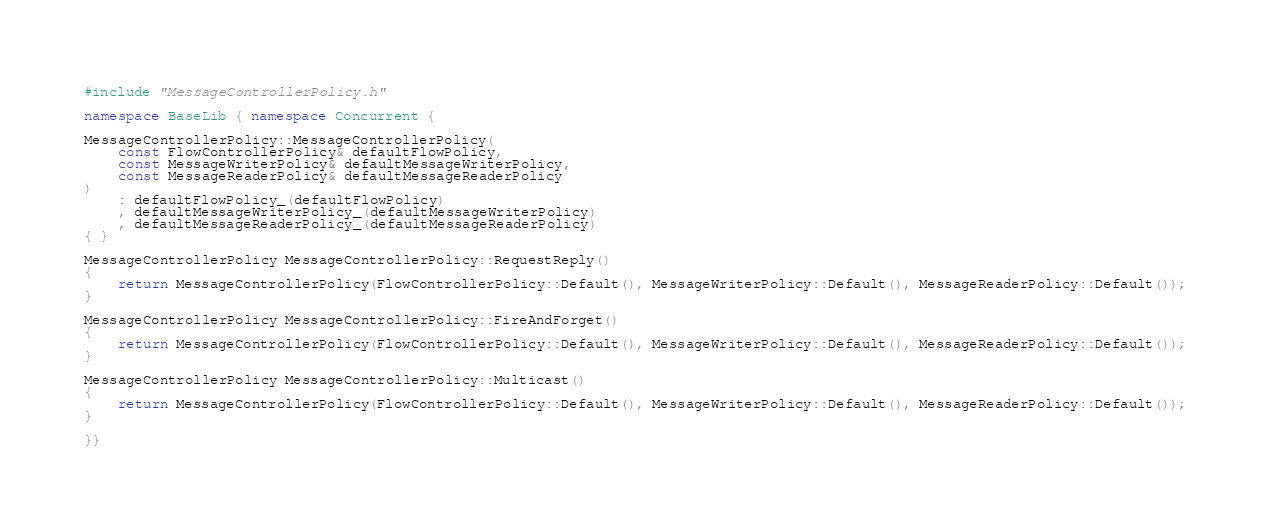<code> <loc_0><loc_0><loc_500><loc_500><_C++_>#include "MessageControllerPolicy.h"

namespace BaseLib { namespace Concurrent {

MessageControllerPolicy::MessageControllerPolicy(
    const FlowControllerPolicy& defaultFlowPolicy,
    const MessageWriterPolicy& defaultMessageWriterPolicy,
    const MessageReaderPolicy& defaultMessageReaderPolicy
)
    : defaultFlowPolicy_(defaultFlowPolicy)
    , defaultMessageWriterPolicy_(defaultMessageWriterPolicy)
    , defaultMessageReaderPolicy_(defaultMessageReaderPolicy)
{ }

MessageControllerPolicy MessageControllerPolicy::RequestReply()
{
    return MessageControllerPolicy(FlowControllerPolicy::Default(), MessageWriterPolicy::Default(), MessageReaderPolicy::Default());
}

MessageControllerPolicy MessageControllerPolicy::FireAndForget()
{
    return MessageControllerPolicy(FlowControllerPolicy::Default(), MessageWriterPolicy::Default(), MessageReaderPolicy::Default());
}

MessageControllerPolicy MessageControllerPolicy::Multicast()
{
    return MessageControllerPolicy(FlowControllerPolicy::Default(), MessageWriterPolicy::Default(), MessageReaderPolicy::Default());
}

}}
</code> 